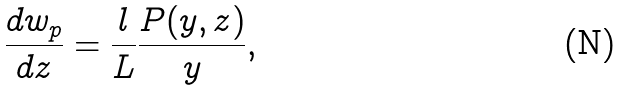<formula> <loc_0><loc_0><loc_500><loc_500>\frac { d w _ { p } } { d z } = \frac { l } { L } \frac { P ( y , z ) } { y } ,</formula> 